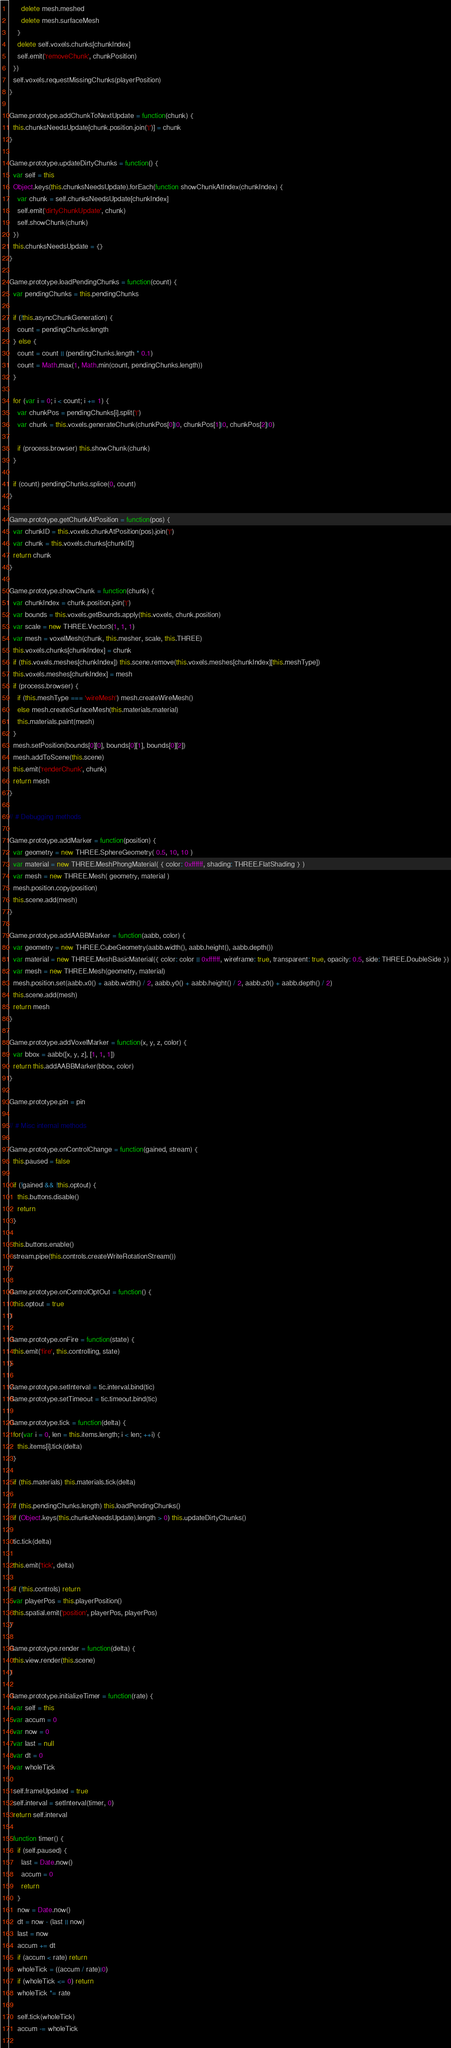<code> <loc_0><loc_0><loc_500><loc_500><_JavaScript_>      delete mesh.meshed
      delete mesh.surfaceMesh
    }
    delete self.voxels.chunks[chunkIndex]
    self.emit('removeChunk', chunkPosition)
  })
  self.voxels.requestMissingChunks(playerPosition)
}

Game.prototype.addChunkToNextUpdate = function(chunk) {
  this.chunksNeedsUpdate[chunk.position.join('|')] = chunk
}

Game.prototype.updateDirtyChunks = function() {
  var self = this
  Object.keys(this.chunksNeedsUpdate).forEach(function showChunkAtIndex(chunkIndex) {
    var chunk = self.chunksNeedsUpdate[chunkIndex]
    self.emit('dirtyChunkUpdate', chunk)
    self.showChunk(chunk)
  })
  this.chunksNeedsUpdate = {}
}

Game.prototype.loadPendingChunks = function(count) {
  var pendingChunks = this.pendingChunks

  if (!this.asyncChunkGeneration) {
    count = pendingChunks.length
  } else {
    count = count || (pendingChunks.length * 0.1)
    count = Math.max(1, Math.min(count, pendingChunks.length))
  }

  for (var i = 0; i < count; i += 1) {
    var chunkPos = pendingChunks[i].split('|')
    var chunk = this.voxels.generateChunk(chunkPos[0]|0, chunkPos[1]|0, chunkPos[2]|0)

    if (process.browser) this.showChunk(chunk)
  }

  if (count) pendingChunks.splice(0, count)
}

Game.prototype.getChunkAtPosition = function(pos) {
  var chunkID = this.voxels.chunkAtPosition(pos).join('|')
  var chunk = this.voxels.chunks[chunkID]
  return chunk
}

Game.prototype.showChunk = function(chunk) {
  var chunkIndex = chunk.position.join('|')
  var bounds = this.voxels.getBounds.apply(this.voxels, chunk.position)
  var scale = new THREE.Vector3(1, 1, 1)
  var mesh = voxelMesh(chunk, this.mesher, scale, this.THREE)
  this.voxels.chunks[chunkIndex] = chunk
  if (this.voxels.meshes[chunkIndex]) this.scene.remove(this.voxels.meshes[chunkIndex][this.meshType])
  this.voxels.meshes[chunkIndex] = mesh
  if (process.browser) {
    if (this.meshType === 'wireMesh') mesh.createWireMesh()
    else mesh.createSurfaceMesh(this.materials.material)
    this.materials.paint(mesh)
  }
  mesh.setPosition(bounds[0][0], bounds[0][1], bounds[0][2])
  mesh.addToScene(this.scene)
  this.emit('renderChunk', chunk)
  return mesh
}

// # Debugging methods

Game.prototype.addMarker = function(position) {
  var geometry = new THREE.SphereGeometry( 0.5, 10, 10 )
  var material = new THREE.MeshPhongMaterial( { color: 0xffffff, shading: THREE.FlatShading } )
  var mesh = new THREE.Mesh( geometry, material )
  mesh.position.copy(position)
  this.scene.add(mesh)
}

Game.prototype.addAABBMarker = function(aabb, color) {
  var geometry = new THREE.CubeGeometry(aabb.width(), aabb.height(), aabb.depth())
  var material = new THREE.MeshBasicMaterial({ color: color || 0xffffff, wireframe: true, transparent: true, opacity: 0.5, side: THREE.DoubleSide })
  var mesh = new THREE.Mesh(geometry, material)
  mesh.position.set(aabb.x0() + aabb.width() / 2, aabb.y0() + aabb.height() / 2, aabb.z0() + aabb.depth() / 2)
  this.scene.add(mesh)
  return mesh
}

Game.prototype.addVoxelMarker = function(x, y, z, color) {
  var bbox = aabb([x, y, z], [1, 1, 1])
  return this.addAABBMarker(bbox, color)
}

Game.prototype.pin = pin

// # Misc internal methods

Game.prototype.onControlChange = function(gained, stream) {
  this.paused = false

  if (!gained && !this.optout) {
    this.buttons.disable()
    return
  }

  this.buttons.enable()
  stream.pipe(this.controls.createWriteRotationStream())
}

Game.prototype.onControlOptOut = function() {
  this.optout = true
}

Game.prototype.onFire = function(state) {
  this.emit('fire', this.controlling, state)
}

Game.prototype.setInterval = tic.interval.bind(tic)
Game.prototype.setTimeout = tic.timeout.bind(tic)

Game.prototype.tick = function(delta) {
  for(var i = 0, len = this.items.length; i < len; ++i) {
    this.items[i].tick(delta)
  }
  
  if (this.materials) this.materials.tick(delta)

  if (this.pendingChunks.length) this.loadPendingChunks()
  if (Object.keys(this.chunksNeedsUpdate).length > 0) this.updateDirtyChunks()
  
  tic.tick(delta)

  this.emit('tick', delta)
  
  if (!this.controls) return
  var playerPos = this.playerPosition()
  this.spatial.emit('position', playerPos, playerPos)
}

Game.prototype.render = function(delta) {
  this.view.render(this.scene)
}

Game.prototype.initializeTimer = function(rate) {
  var self = this
  var accum = 0
  var now = 0
  var last = null
  var dt = 0
  var wholeTick
  
  self.frameUpdated = true
  self.interval = setInterval(timer, 0)
  return self.interval
  
  function timer() {
    if (self.paused) {
      last = Date.now()
      accum = 0
      return
    }
    now = Date.now()
    dt = now - (last || now)
    last = now
    accum += dt
    if (accum < rate) return
    wholeTick = ((accum / rate)|0)
    if (wholeTick <= 0) return
    wholeTick *= rate
    
    self.tick(wholeTick)
    accum -= wholeTick
    </code> 